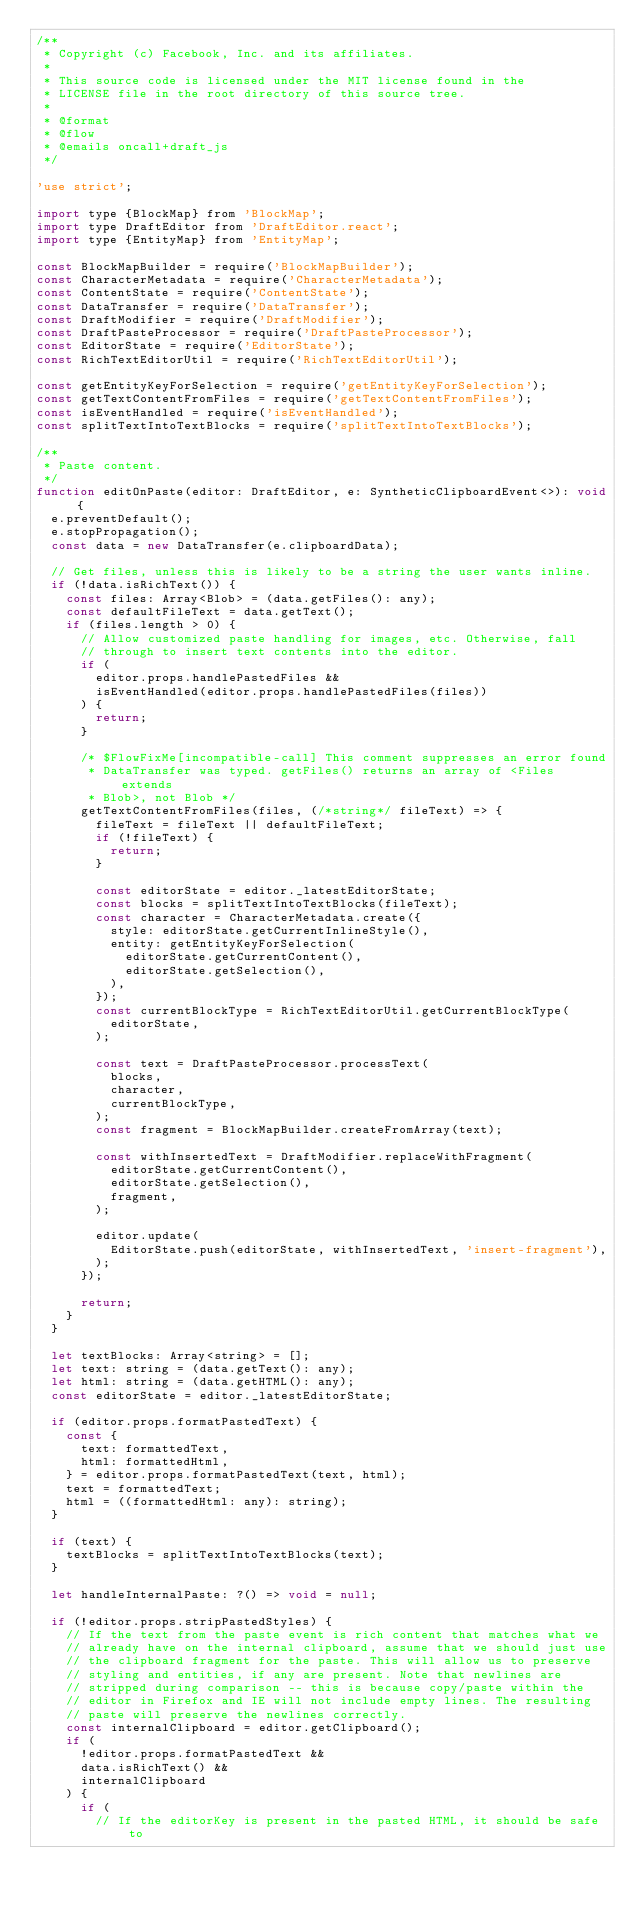Convert code to text. <code><loc_0><loc_0><loc_500><loc_500><_JavaScript_>/**
 * Copyright (c) Facebook, Inc. and its affiliates.
 *
 * This source code is licensed under the MIT license found in the
 * LICENSE file in the root directory of this source tree.
 *
 * @format
 * @flow
 * @emails oncall+draft_js
 */

'use strict';

import type {BlockMap} from 'BlockMap';
import type DraftEditor from 'DraftEditor.react';
import type {EntityMap} from 'EntityMap';

const BlockMapBuilder = require('BlockMapBuilder');
const CharacterMetadata = require('CharacterMetadata');
const ContentState = require('ContentState');
const DataTransfer = require('DataTransfer');
const DraftModifier = require('DraftModifier');
const DraftPasteProcessor = require('DraftPasteProcessor');
const EditorState = require('EditorState');
const RichTextEditorUtil = require('RichTextEditorUtil');

const getEntityKeyForSelection = require('getEntityKeyForSelection');
const getTextContentFromFiles = require('getTextContentFromFiles');
const isEventHandled = require('isEventHandled');
const splitTextIntoTextBlocks = require('splitTextIntoTextBlocks');

/**
 * Paste content.
 */
function editOnPaste(editor: DraftEditor, e: SyntheticClipboardEvent<>): void {
  e.preventDefault();
  e.stopPropagation();
  const data = new DataTransfer(e.clipboardData);

  // Get files, unless this is likely to be a string the user wants inline.
  if (!data.isRichText()) {
    const files: Array<Blob> = (data.getFiles(): any);
    const defaultFileText = data.getText();
    if (files.length > 0) {
      // Allow customized paste handling for images, etc. Otherwise, fall
      // through to insert text contents into the editor.
      if (
        editor.props.handlePastedFiles &&
        isEventHandled(editor.props.handlePastedFiles(files))
      ) {
        return;
      }

      /* $FlowFixMe[incompatible-call] This comment suppresses an error found
       * DataTransfer was typed. getFiles() returns an array of <Files extends
       * Blob>, not Blob */
      getTextContentFromFiles(files, (/*string*/ fileText) => {
        fileText = fileText || defaultFileText;
        if (!fileText) {
          return;
        }

        const editorState = editor._latestEditorState;
        const blocks = splitTextIntoTextBlocks(fileText);
        const character = CharacterMetadata.create({
          style: editorState.getCurrentInlineStyle(),
          entity: getEntityKeyForSelection(
            editorState.getCurrentContent(),
            editorState.getSelection(),
          ),
        });
        const currentBlockType = RichTextEditorUtil.getCurrentBlockType(
          editorState,
        );

        const text = DraftPasteProcessor.processText(
          blocks,
          character,
          currentBlockType,
        );
        const fragment = BlockMapBuilder.createFromArray(text);

        const withInsertedText = DraftModifier.replaceWithFragment(
          editorState.getCurrentContent(),
          editorState.getSelection(),
          fragment,
        );

        editor.update(
          EditorState.push(editorState, withInsertedText, 'insert-fragment'),
        );
      });

      return;
    }
  }

  let textBlocks: Array<string> = [];
  let text: string = (data.getText(): any);
  let html: string = (data.getHTML(): any);
  const editorState = editor._latestEditorState;

  if (editor.props.formatPastedText) {
    const {
      text: formattedText,
      html: formattedHtml,
    } = editor.props.formatPastedText(text, html);
    text = formattedText;
    html = ((formattedHtml: any): string);
  }

  if (text) {
    textBlocks = splitTextIntoTextBlocks(text);
  }

  let handleInternalPaste: ?() => void = null;

  if (!editor.props.stripPastedStyles) {
    // If the text from the paste event is rich content that matches what we
    // already have on the internal clipboard, assume that we should just use
    // the clipboard fragment for the paste. This will allow us to preserve
    // styling and entities, if any are present. Note that newlines are
    // stripped during comparison -- this is because copy/paste within the
    // editor in Firefox and IE will not include empty lines. The resulting
    // paste will preserve the newlines correctly.
    const internalClipboard = editor.getClipboard();
    if (
      !editor.props.formatPastedText &&
      data.isRichText() &&
      internalClipboard
    ) {
      if (
        // If the editorKey is present in the pasted HTML, it should be safe to</code> 